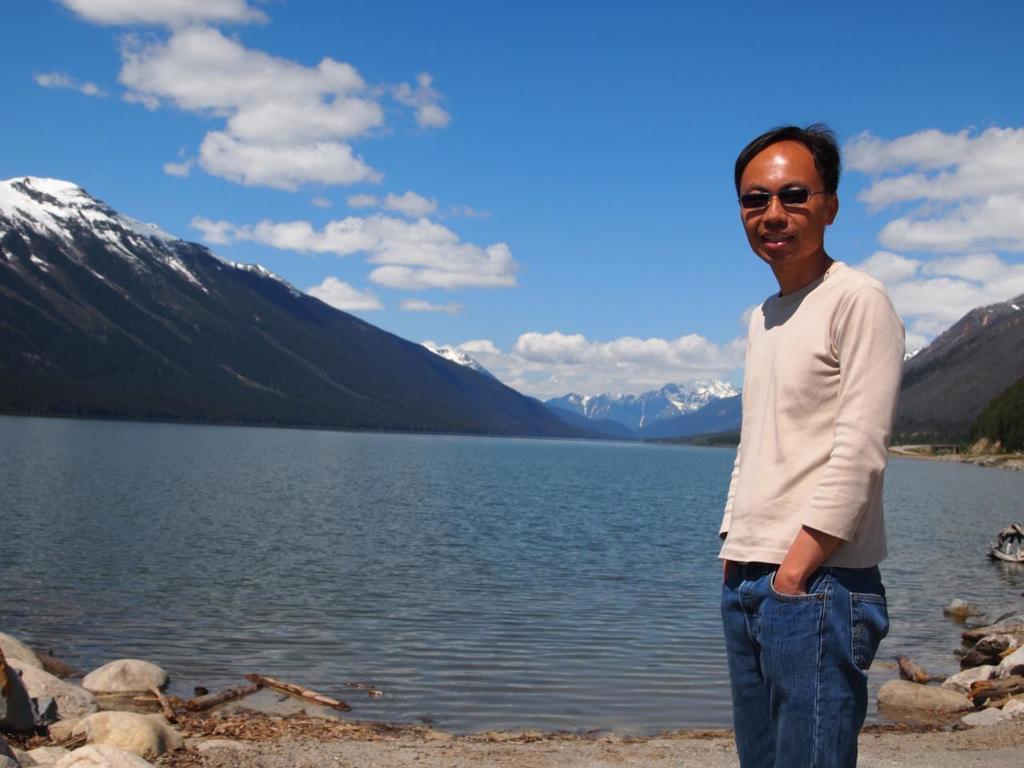Please provide a concise description of this image. Here we can see a man posing to a camera and he has goggles. This is water. In the background we can see mountain and sky with clouds. 